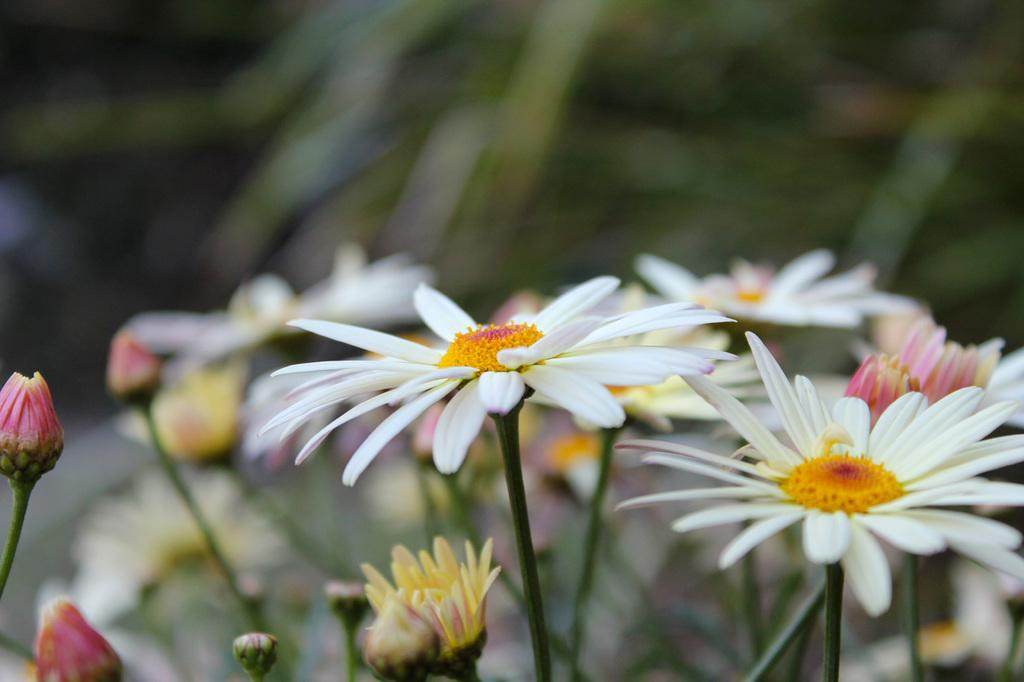What type of living organisms can be seen in the image? There are flowers in the image. What stage of growth are the plants in the image? There are buds on the plants in the image, indicating they are in the early stages of growth. What can be seen in the background of the image? There are plants in the background of the image. What type of ink is being used to color the stove in the image? There is no stove present in the image, so it is not possible to determine what type of ink might be used to color it. 